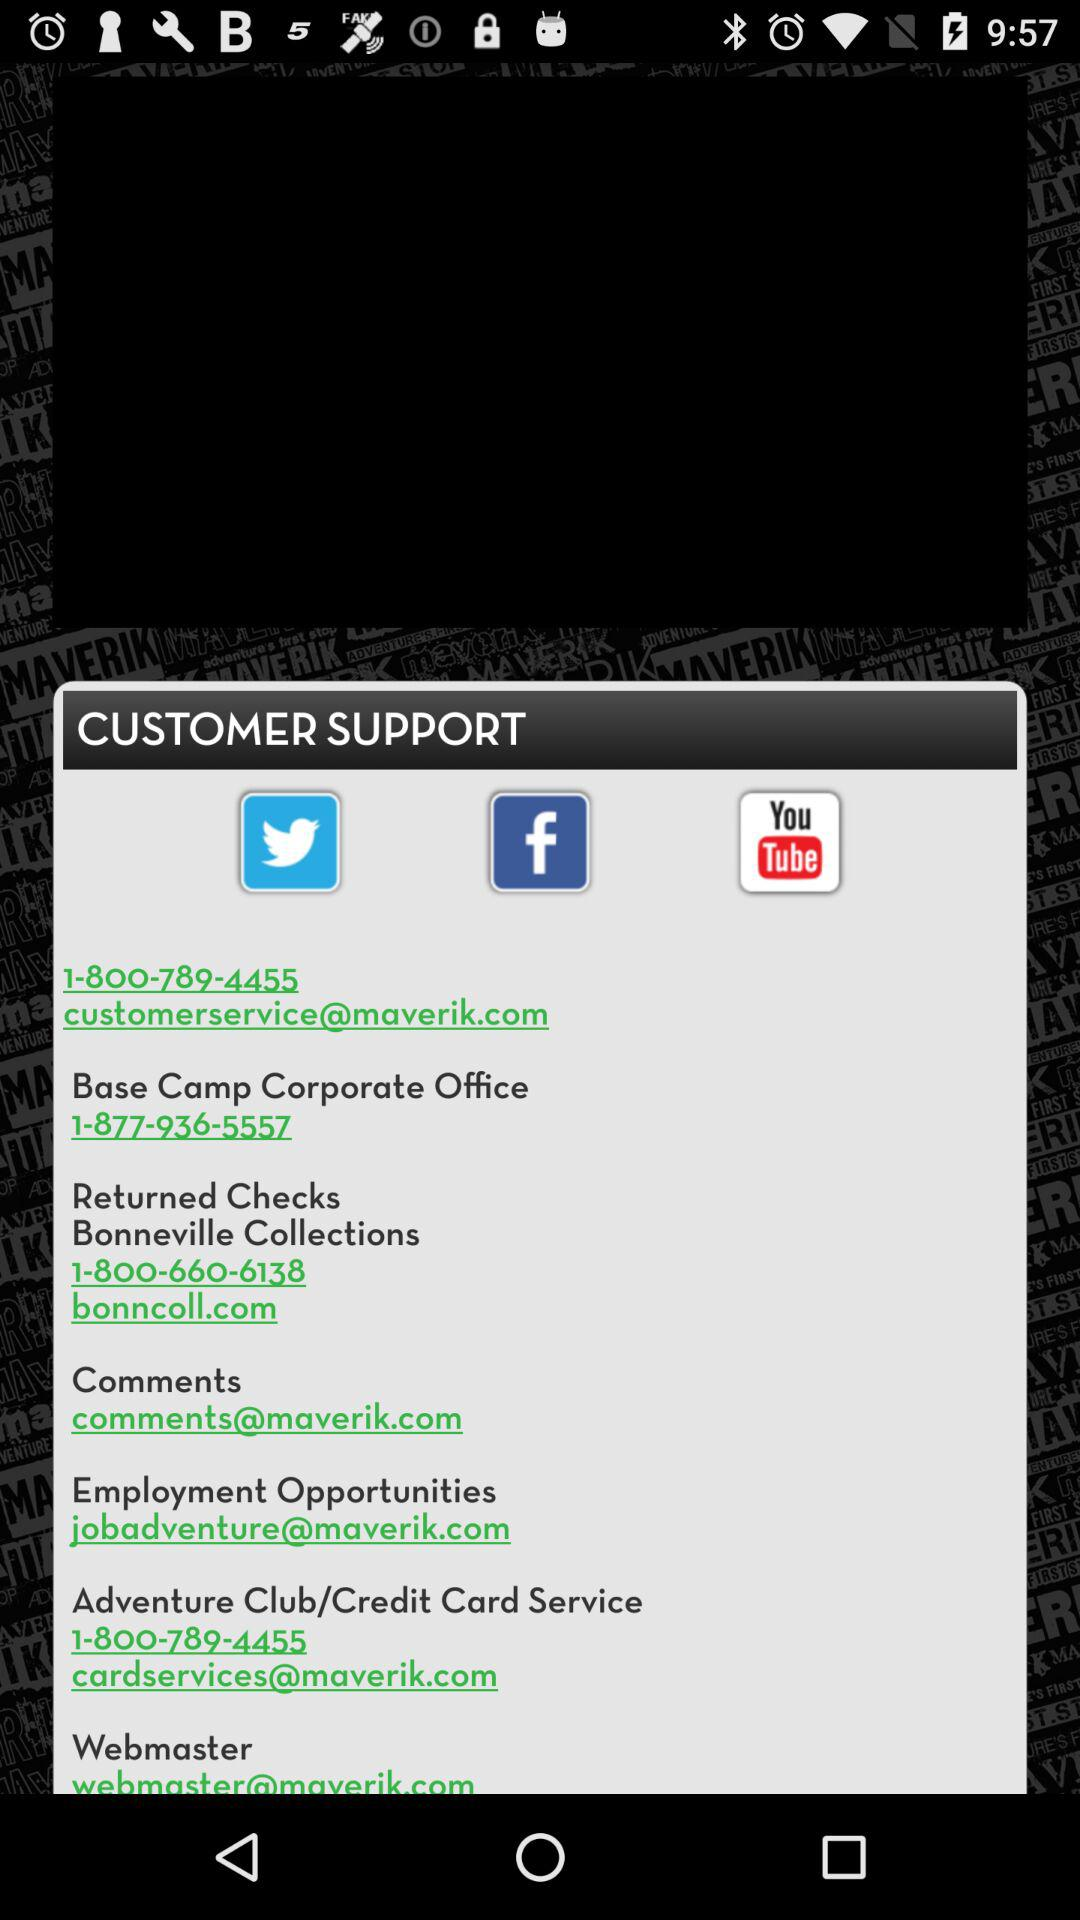Does the "Webmaster" have a contact number?
When the provided information is insufficient, respond with <no answer>. <no answer> 